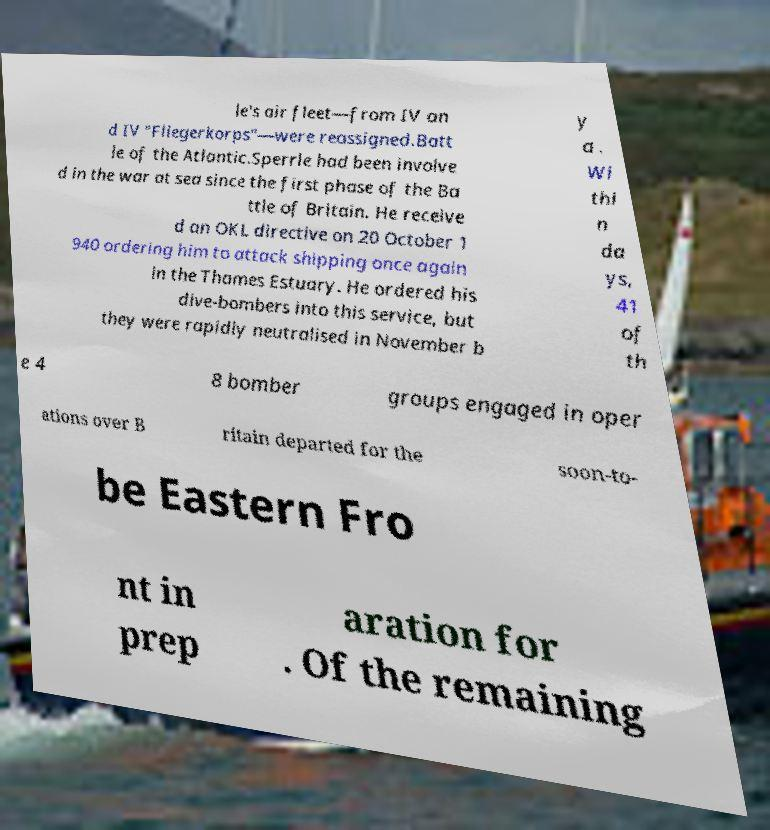Can you accurately transcribe the text from the provided image for me? le's air fleet—from IV an d IV "Fliegerkorps"—were reassigned.Batt le of the Atlantic.Sperrle had been involve d in the war at sea since the first phase of the Ba ttle of Britain. He receive d an OKL directive on 20 October 1 940 ordering him to attack shipping once again in the Thames Estuary. He ordered his dive-bombers into this service, but they were rapidly neutralised in November b y a . Wi thi n da ys, 41 of th e 4 8 bomber groups engaged in oper ations over B ritain departed for the soon-to- be Eastern Fro nt in prep aration for . Of the remaining 